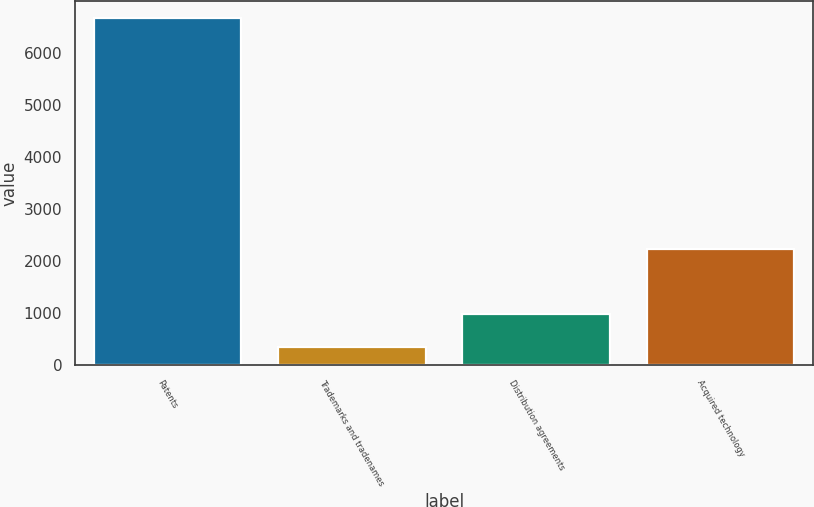<chart> <loc_0><loc_0><loc_500><loc_500><bar_chart><fcel>Patents<fcel>Trademarks and tradenames<fcel>Distribution agreements<fcel>Acquired technology<nl><fcel>6658<fcel>339<fcel>970.9<fcel>2228<nl></chart> 